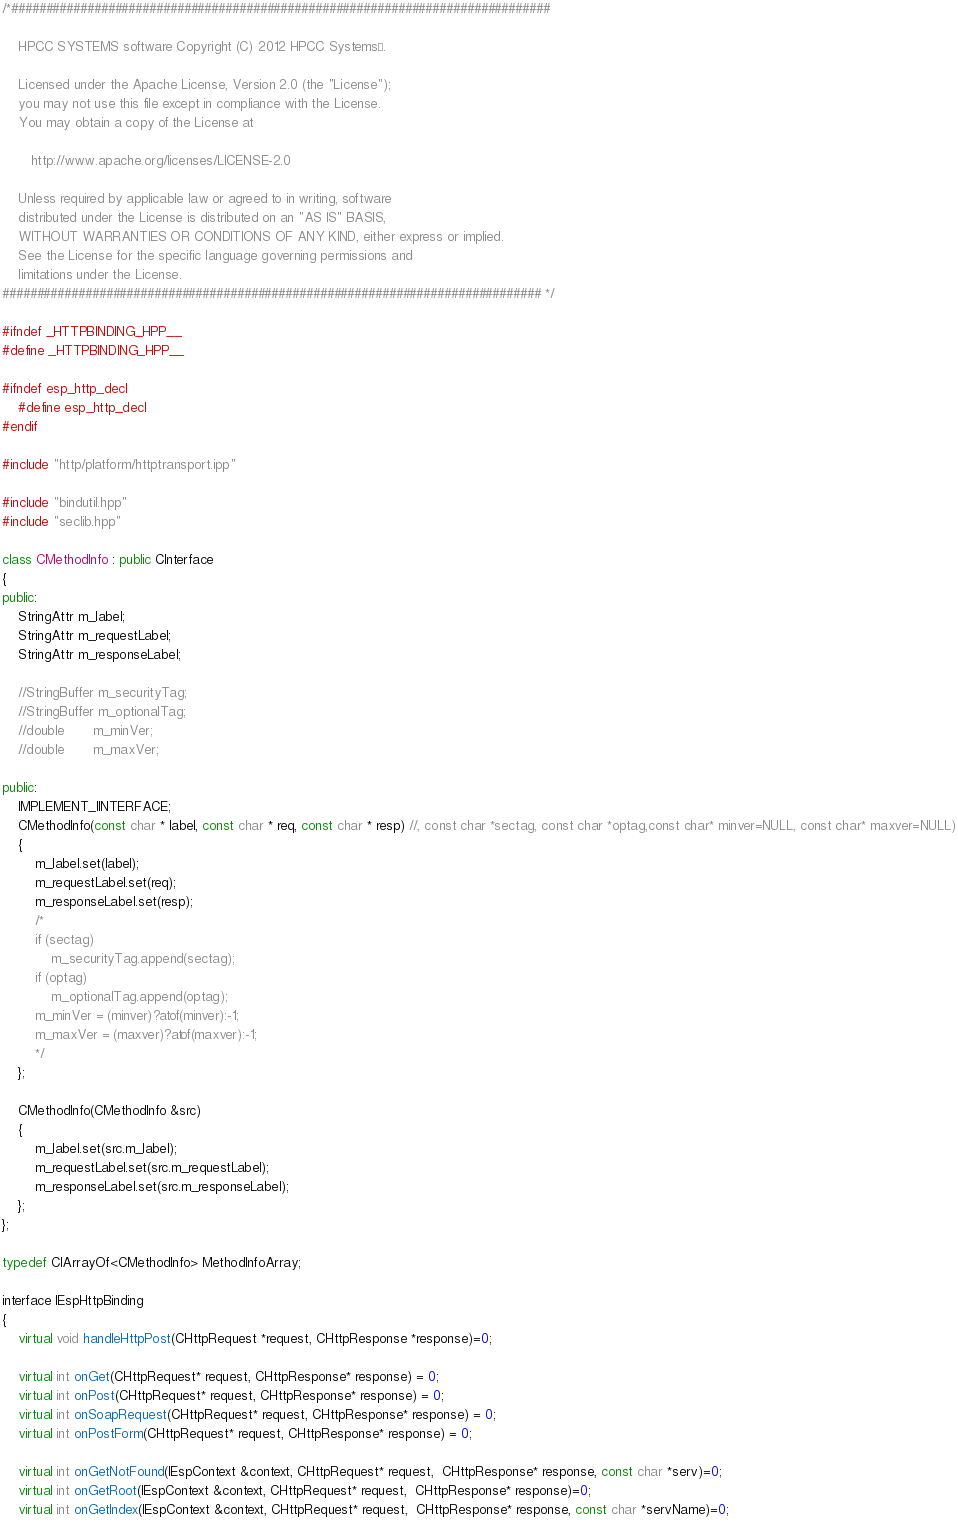Convert code to text. <code><loc_0><loc_0><loc_500><loc_500><_C++_>/*##############################################################################

    HPCC SYSTEMS software Copyright (C) 2012 HPCC Systems®.

    Licensed under the Apache License, Version 2.0 (the "License");
    you may not use this file except in compliance with the License.
    You may obtain a copy of the License at

       http://www.apache.org/licenses/LICENSE-2.0

    Unless required by applicable law or agreed to in writing, software
    distributed under the License is distributed on an "AS IS" BASIS,
    WITHOUT WARRANTIES OR CONDITIONS OF ANY KIND, either express or implied.
    See the License for the specific language governing permissions and
    limitations under the License.
############################################################################## */

#ifndef _HTTPBINDING_HPP__
#define _HTTPBINDING_HPP__

#ifndef esp_http_decl
    #define esp_http_decl
#endif

#include "http/platform/httptransport.ipp"

#include "bindutil.hpp"
#include "seclib.hpp"

class CMethodInfo : public CInterface
{
public:
    StringAttr m_label;
    StringAttr m_requestLabel;
    StringAttr m_responseLabel;

    //StringBuffer m_securityTag;
    //StringBuffer m_optionalTag;
    //double       m_minVer;
    //double       m_maxVer;

public:
    IMPLEMENT_IINTERFACE;
    CMethodInfo(const char * label, const char * req, const char * resp) //, const char *sectag, const char *optag,const char* minver=NULL, const char* maxver=NULL)
    {
        m_label.set(label);
        m_requestLabel.set(req);
        m_responseLabel.set(resp);
        /*
        if (sectag)
            m_securityTag.append(sectag);
        if (optag)
            m_optionalTag.append(optag);
        m_minVer = (minver)?atof(minver):-1;
        m_maxVer = (maxver)?atof(maxver):-1;
        */
    };

    CMethodInfo(CMethodInfo &src)
    {
        m_label.set(src.m_label);
        m_requestLabel.set(src.m_requestLabel);
        m_responseLabel.set(src.m_responseLabel);
    };
};

typedef CIArrayOf<CMethodInfo> MethodInfoArray;

interface IEspHttpBinding
{
    virtual void handleHttpPost(CHttpRequest *request, CHttpResponse *response)=0;

    virtual int onGet(CHttpRequest* request, CHttpResponse* response) = 0;
    virtual int onPost(CHttpRequest* request, CHttpResponse* response) = 0;
    virtual int onSoapRequest(CHttpRequest* request, CHttpResponse* response) = 0;
    virtual int onPostForm(CHttpRequest* request, CHttpResponse* response) = 0;

    virtual int onGetNotFound(IEspContext &context, CHttpRequest* request,  CHttpResponse* response, const char *serv)=0;
    virtual int onGetRoot(IEspContext &context, CHttpRequest* request,  CHttpResponse* response)=0;
    virtual int onGetIndex(IEspContext &context, CHttpRequest* request,  CHttpResponse* response, const char *servName)=0;</code> 